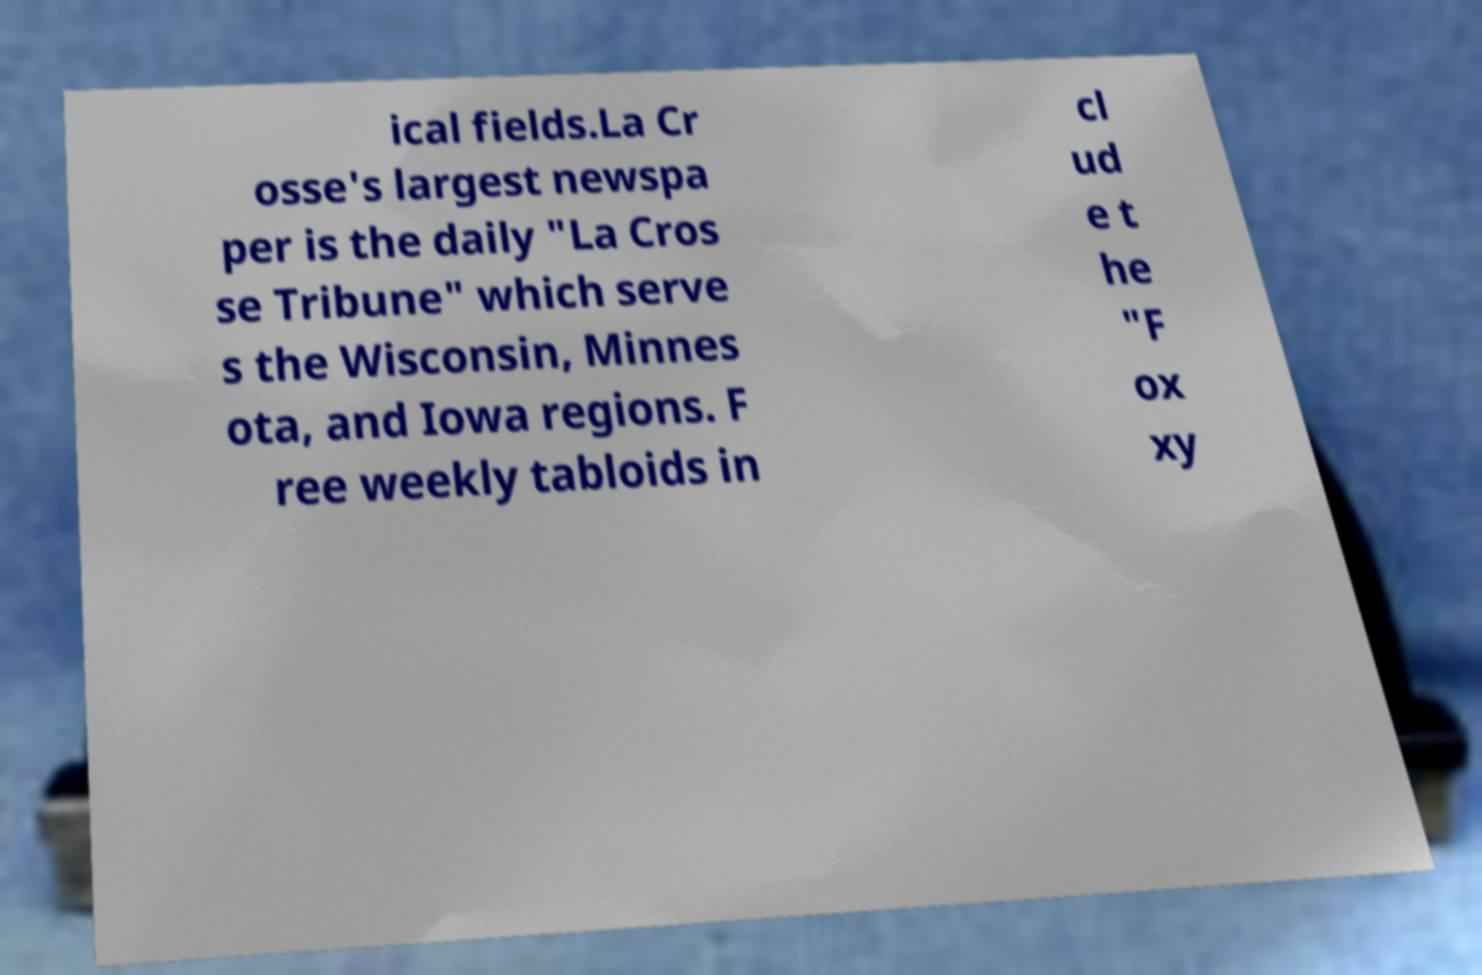Could you assist in decoding the text presented in this image and type it out clearly? ical fields.La Cr osse's largest newspa per is the daily "La Cros se Tribune" which serve s the Wisconsin, Minnes ota, and Iowa regions. F ree weekly tabloids in cl ud e t he "F ox xy 